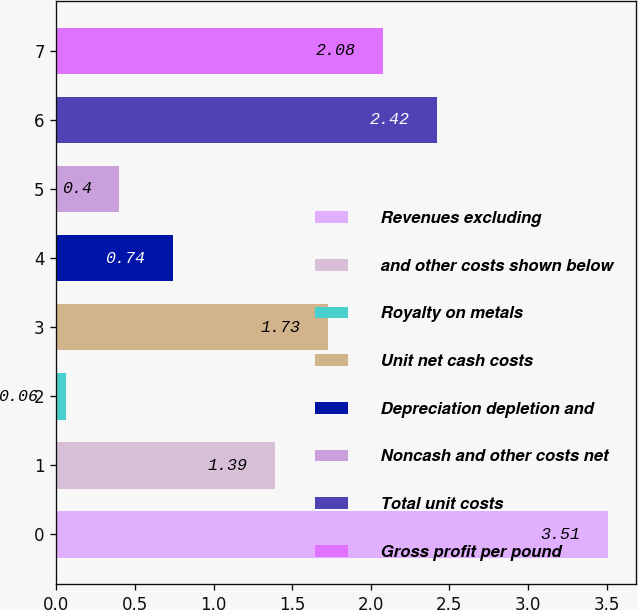Convert chart. <chart><loc_0><loc_0><loc_500><loc_500><bar_chart><fcel>Revenues excluding<fcel>and other costs shown below<fcel>Royalty on metals<fcel>Unit net cash costs<fcel>Depreciation depletion and<fcel>Noncash and other costs net<fcel>Total unit costs<fcel>Gross profit per pound<nl><fcel>3.51<fcel>1.39<fcel>0.06<fcel>1.73<fcel>0.74<fcel>0.4<fcel>2.42<fcel>2.08<nl></chart> 